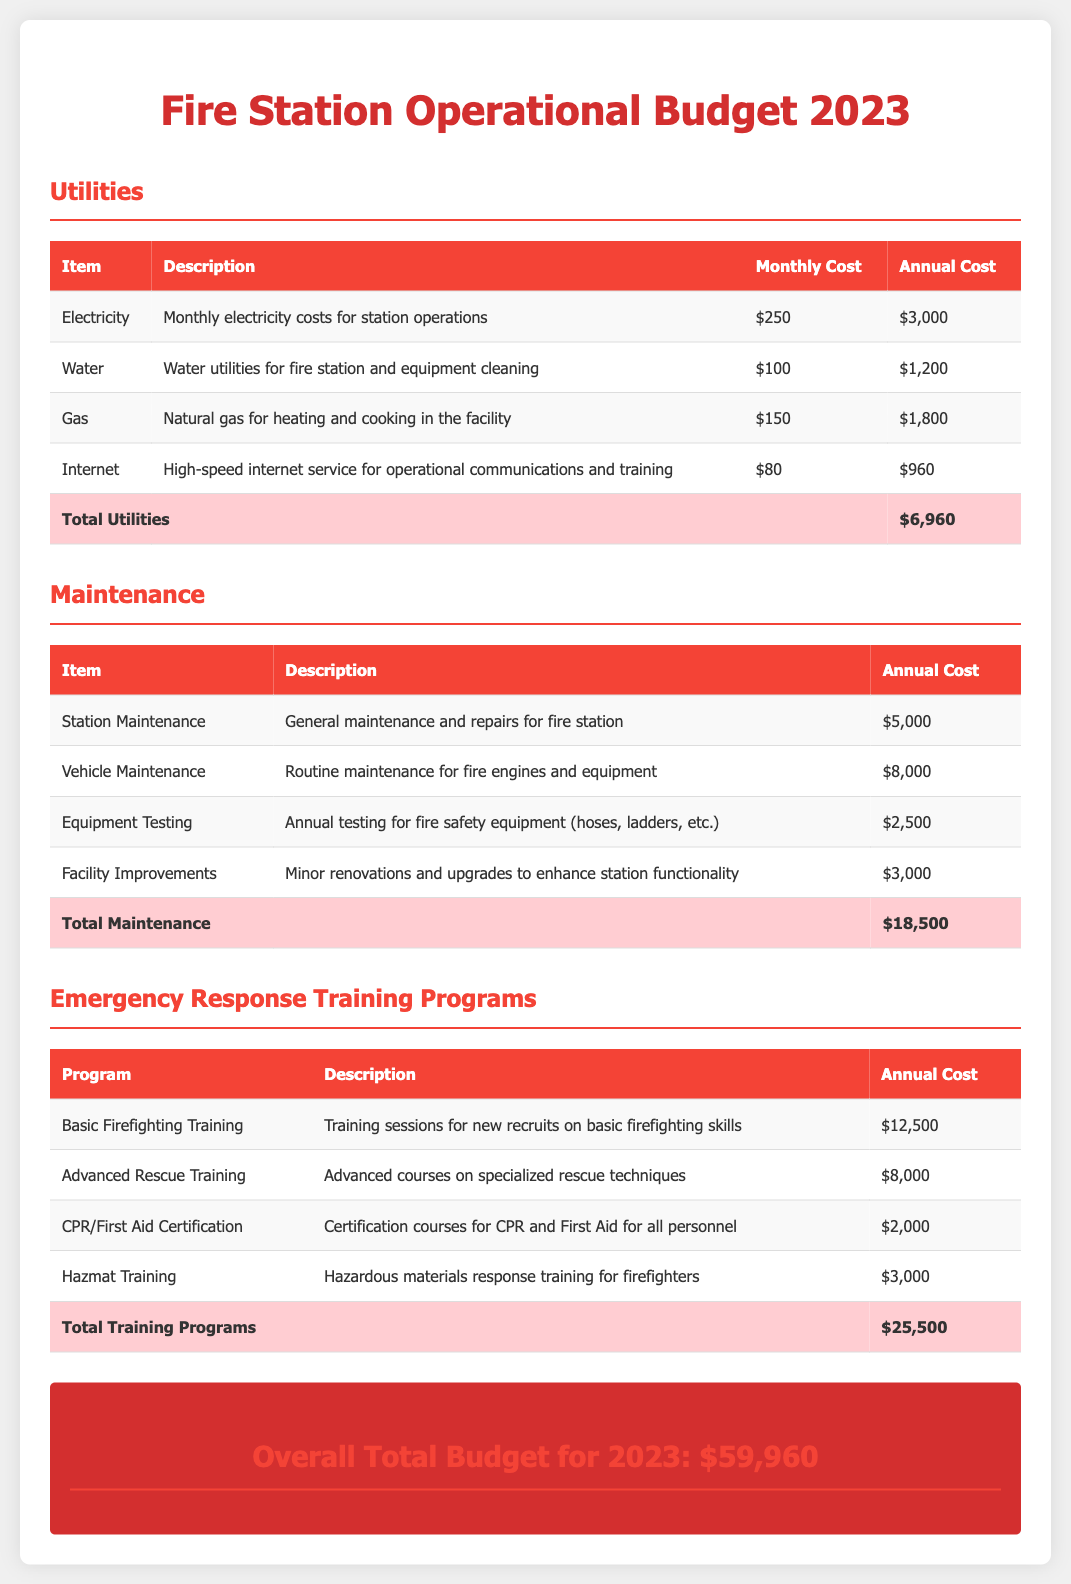What is the total cost for utilities? The total cost for utilities is provided at the bottom of the Utilities section, which sums the individual monthly and annual costs for each utility item.
Answer: $6,960 What is the annual cost for Vehicle Maintenance? The annual cost for Vehicle Maintenance is listed in the Maintenance section where each item's cost is detailed.
Answer: $8,000 How much is allocated for Advanced Rescue Training? The allocation for Advanced Rescue Training is found in the Emergency Response Training Programs section, where each program's annual cost is specified.
Answer: $8,000 What is the description for Hazmat Training? The description for Hazmat Training is provided in the Emergency Response Training Programs table under the Description column.
Answer: Hazardous materials response training for firefighters What is the overall total budget for 2023? The overall total budget is calculated by summing all costs in the Utilities, Maintenance, and Emergency Response Training Programs sections.
Answer: $59,960 How many programs are listed under Emergency Response Training Programs? The total number of programs can be counted in the Emergency Response Training Programs section, where each program is listed with its details.
Answer: 4 What is the cost for CPR/First Aid Certification? The cost for CPR/First Aid Certification is specified in the corresponding row within the Emergency Response Training Programs section.
Answer: $2,000 What item accounts for the highest cost in the Maintenance section? The item with the highest cost in the Maintenance section is identified by comparing the annual costs of each item listed.
Answer: Vehicle Maintenance What monthly utility cost is associated with Internet service? The monthly utility cost associated with Internet service is detailed in the Utilities table under the Monthly Cost column.
Answer: $80 